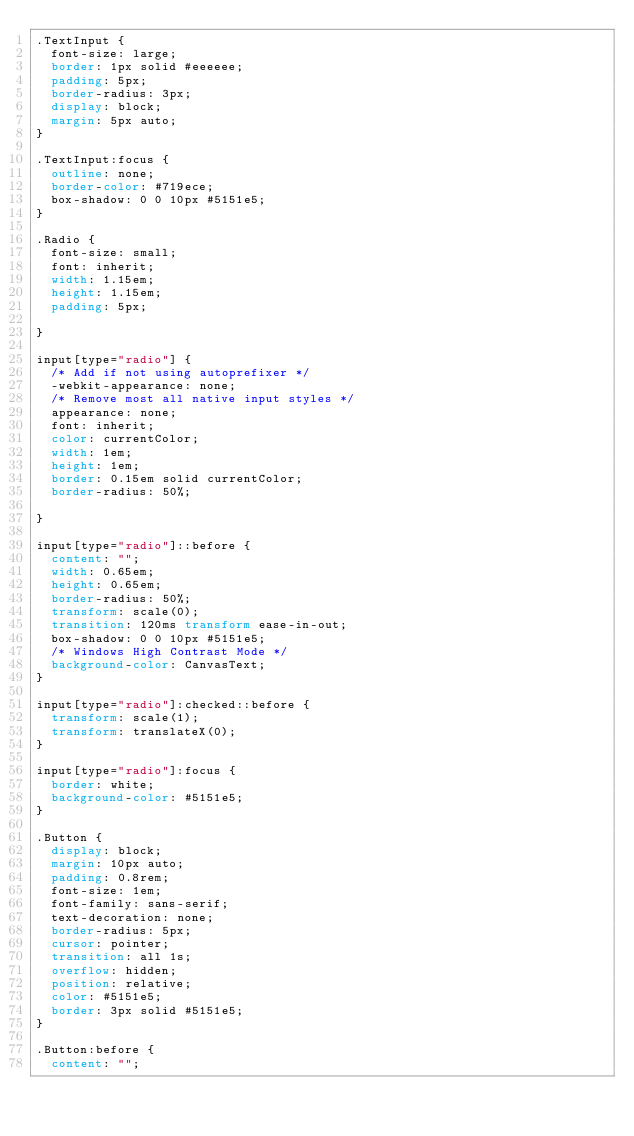Convert code to text. <code><loc_0><loc_0><loc_500><loc_500><_CSS_>.TextInput {
  font-size: large;
  border: 1px solid #eeeeee;
  padding: 5px;
  border-radius: 3px;
  display: block;
  margin: 5px auto;
}

.TextInput:focus {
  outline: none;
  border-color: #719ece;
  box-shadow: 0 0 10px #5151e5;
}

.Radio {
  font-size: small;
  font: inherit;
  width: 1.15em;
  height: 1.15em;
  padding: 5px;

}

input[type="radio"] {
  /* Add if not using autoprefixer */
  -webkit-appearance: none;
  /* Remove most all native input styles */
  appearance: none;
  font: inherit;
  color: currentColor;
  width: 1em;
  height: 1em;
  border: 0.15em solid currentColor;
  border-radius: 50%;

}

input[type="radio"]::before {
  content: "";
  width: 0.65em;
  height: 0.65em;
  border-radius: 50%;
  transform: scale(0);
  transition: 120ms transform ease-in-out;
  box-shadow: 0 0 10px #5151e5;
  /* Windows High Contrast Mode */
  background-color: CanvasText;
}

input[type="radio"]:checked::before {
  transform: scale(1);
  transform: translateX(0);
}

input[type="radio"]:focus {
  border: white;
  background-color: #5151e5;
}

.Button {
  display: block;
  margin: 10px auto;
  padding: 0.8rem;
  font-size: 1em;
  font-family: sans-serif;
  text-decoration: none;
  border-radius: 5px;
  cursor: pointer;
  transition: all 1s;
  overflow: hidden;
  position: relative;
  color: #5151e5;
  border: 3px solid #5151e5;
}

.Button:before {
  content: "";</code> 